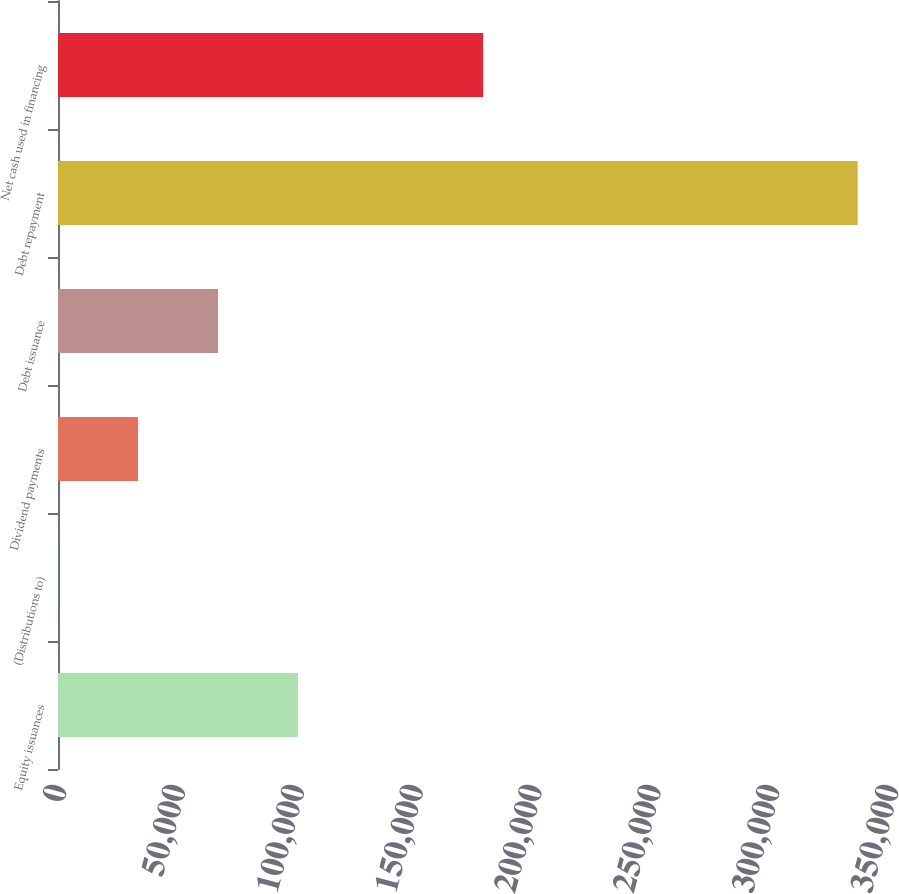<chart> <loc_0><loc_0><loc_500><loc_500><bar_chart><fcel>Equity issuances<fcel>(Distributions to)<fcel>Dividend payments<fcel>Debt issuance<fcel>Debt repayment<fcel>Net cash used in financing<nl><fcel>100953<fcel>38<fcel>33676.2<fcel>67314.4<fcel>336420<fcel>178851<nl></chart> 